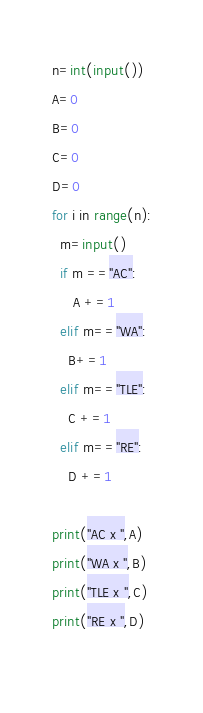Convert code to text. <code><loc_0><loc_0><loc_500><loc_500><_Python_>n=int(input())
A=0
B=0
C=0
D=0
for i in range(n):
  m=input()
  if m =="AC":
     A +=1
  elif m=="WA":
    B+=1
  elif m=="TLE":
    C +=1
  elif m=="RE":
    D +=1

print("AC x ",A)
print("WA x ",B)
print("TLE x ",C)
print("RE x ",D)
  
</code> 